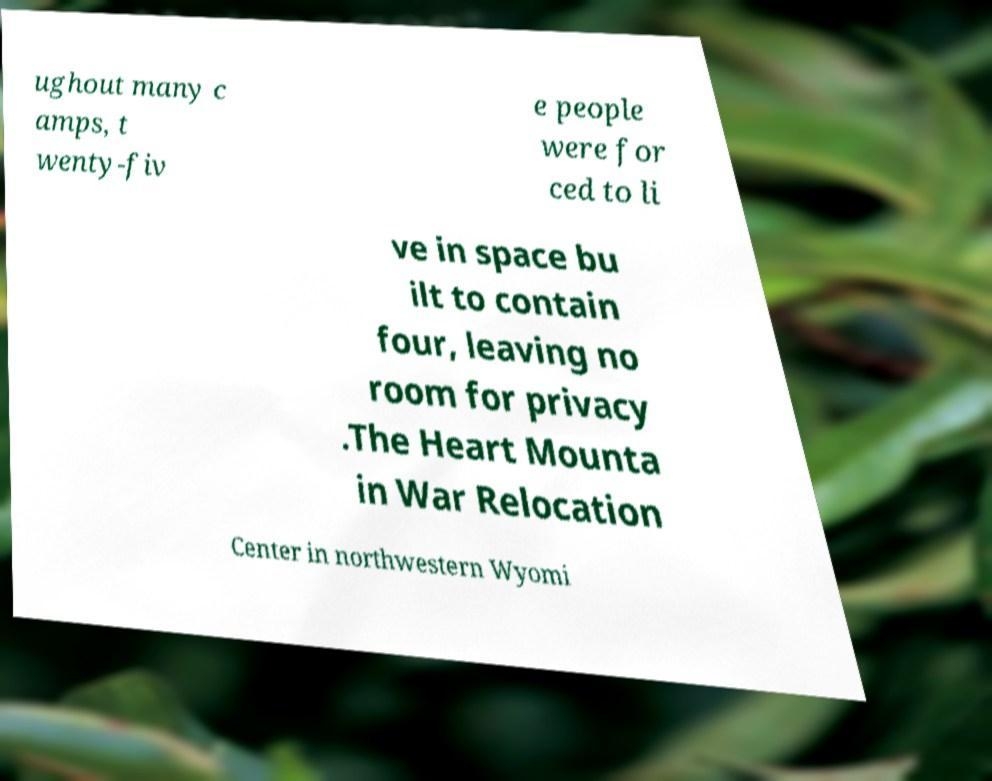Can you accurately transcribe the text from the provided image for me? ughout many c amps, t wenty-fiv e people were for ced to li ve in space bu ilt to contain four, leaving no room for privacy .The Heart Mounta in War Relocation Center in northwestern Wyomi 